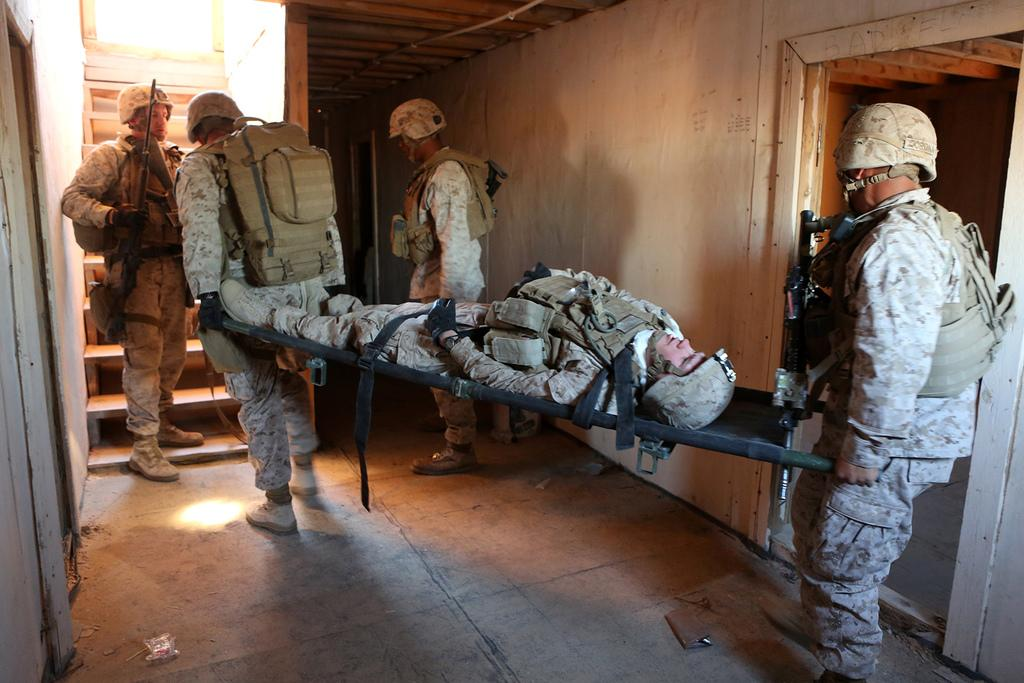How many people are in the image? There are five persons in the image. What are the persons wearing on their heads? The persons are wearing helmets. Where are the persons standing? The persons are standing on the floor. Can you describe the person who is not standing? There is a person lying on a stretcher. What can be seen in the background of the image? There is a wall and steps in the background of the image. What type of bone can be seen in the image? There is no bone present in the image. Can you tell me how many boats are in the harbor in the image? There is no harbor or boats present in the image. 